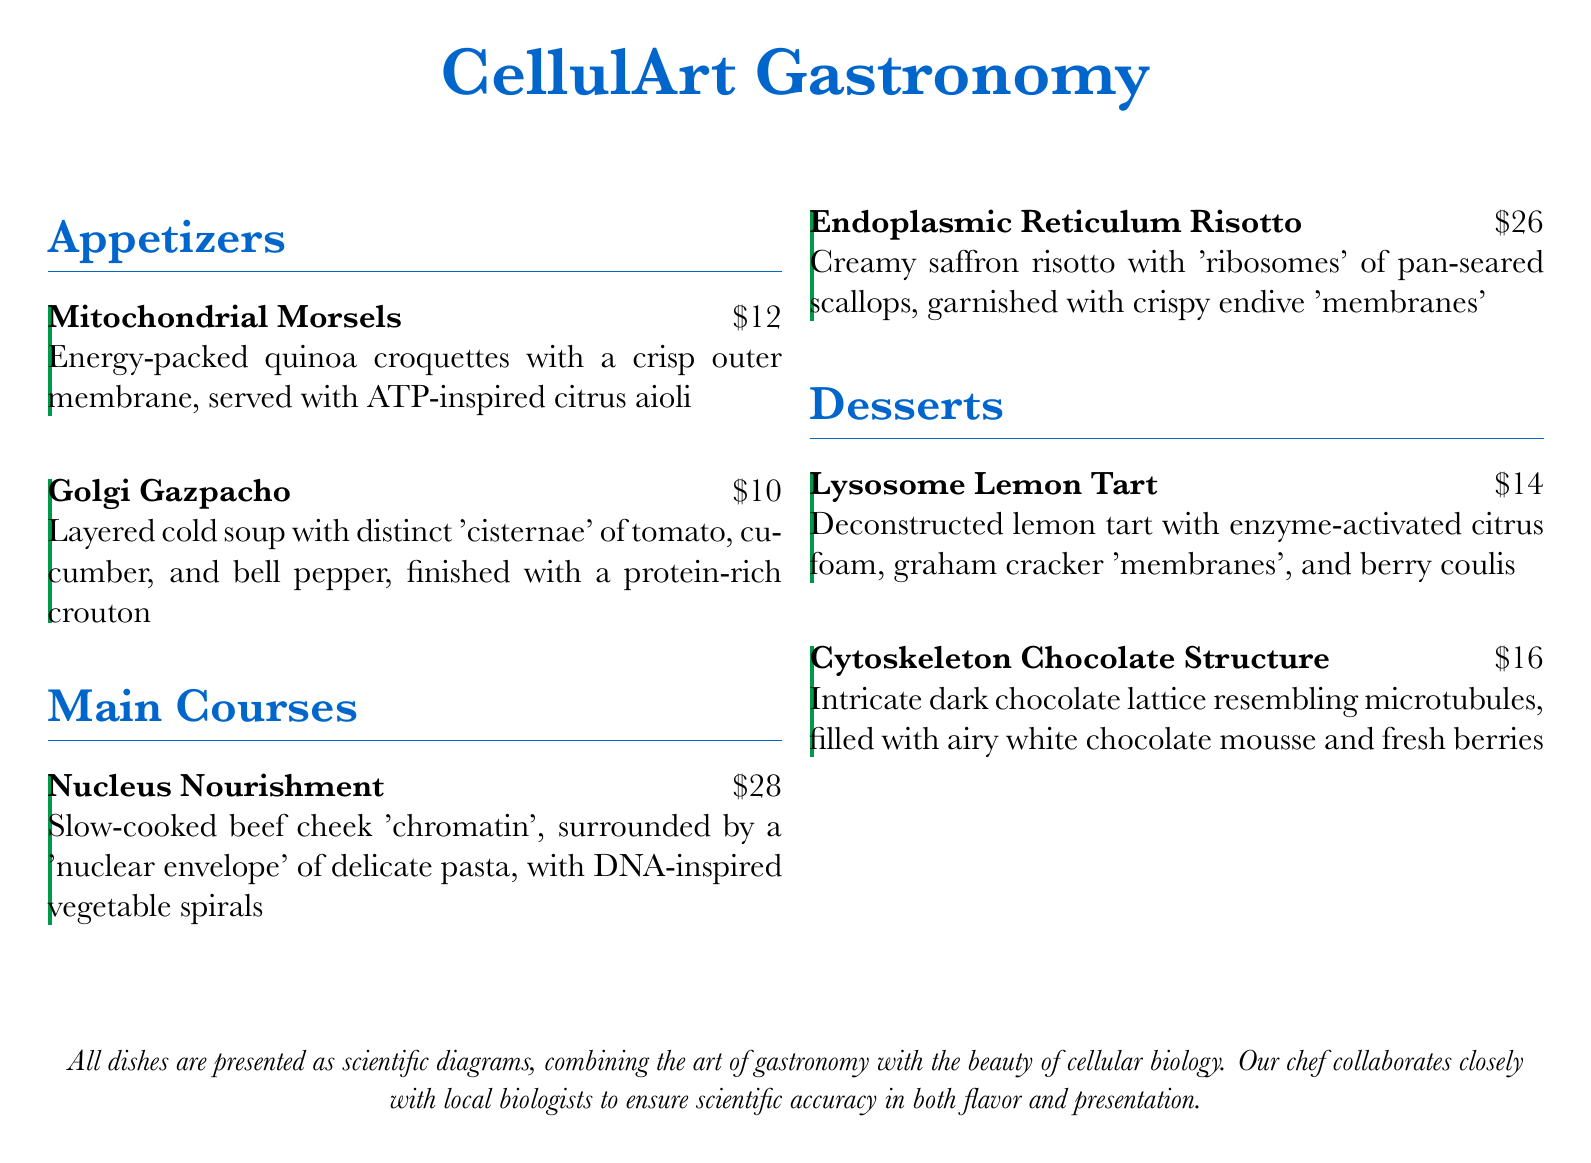What is the name of the first appetizer? The first appetizer listed on the menu is "Mitochondrial Morsels."
Answer: Mitochondrial Morsels How much does the "Endoplasmic Reticulum Risotto" cost? The price of the "Endoplasmic Reticulum Risotto" is mentioned next to the dish.
Answer: $26 What type of foam is featured in the "Lysosome Lemon Tart"? The description of the "Lysosome Lemon Tart" specifies that it includes enzyme-activated citrus foam.
Answer: enzyme-activated How many main courses are listed on the menu? The main courses section includes two dishes.
Answer: 2 Which appetizer includes a crouton? "Golgi Gazpacho" mentions being finished with a protein-rich crouton.
Answer: Golgi Gazpacho What are the 'ribosomes' made of in the "Endoplasmic Reticulum Risotto"? The 'ribosomes' in the dish are identified as pan-seared scallops in the description.
Answer: pan-seared scallops What is the dessert inspired by cellular structures? The dessert names and their descriptions reflect inspiration drawn from cellular biology contexts.
Answer: Cytoskeleton Chocolate Structure What is the theme of the menu? The overarching theme of the menu is suggested by the title "CellulArt Gastronomy."
Answer: CellulArt Gastronomy 